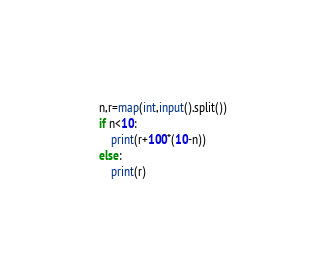<code> <loc_0><loc_0><loc_500><loc_500><_Python_>n,r=map(int,input().split())
if n<10:
	print(r+100*(10-n))
else:
	print(r)</code> 